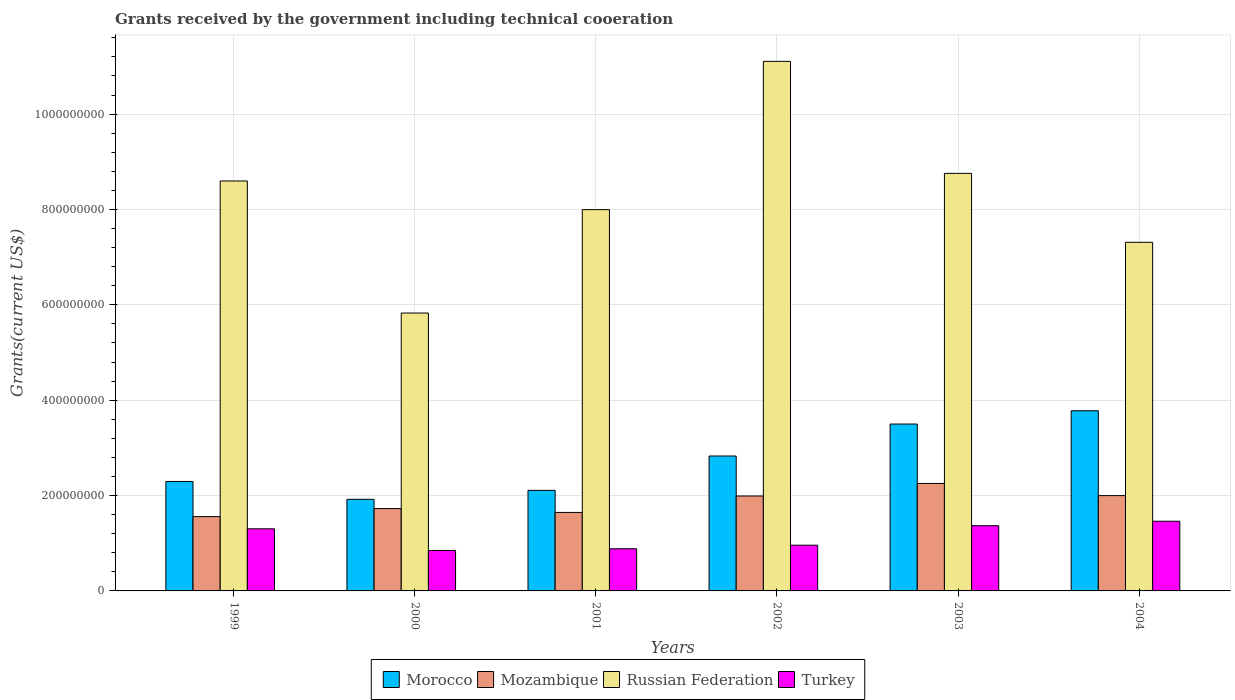How many groups of bars are there?
Ensure brevity in your answer.  6. Are the number of bars on each tick of the X-axis equal?
Provide a succinct answer. Yes. How many bars are there on the 1st tick from the left?
Your response must be concise. 4. What is the total grants received by the government in Russian Federation in 2000?
Provide a succinct answer. 5.83e+08. Across all years, what is the maximum total grants received by the government in Russian Federation?
Offer a very short reply. 1.11e+09. Across all years, what is the minimum total grants received by the government in Mozambique?
Provide a short and direct response. 1.56e+08. In which year was the total grants received by the government in Morocco maximum?
Ensure brevity in your answer.  2004. In which year was the total grants received by the government in Turkey minimum?
Give a very brief answer. 2000. What is the total total grants received by the government in Morocco in the graph?
Your answer should be very brief. 1.64e+09. What is the difference between the total grants received by the government in Turkey in 2001 and that in 2003?
Make the answer very short. -4.84e+07. What is the difference between the total grants received by the government in Russian Federation in 2000 and the total grants received by the government in Turkey in 1999?
Your response must be concise. 4.53e+08. What is the average total grants received by the government in Morocco per year?
Your response must be concise. 2.74e+08. In the year 2003, what is the difference between the total grants received by the government in Turkey and total grants received by the government in Mozambique?
Offer a very short reply. -8.86e+07. In how many years, is the total grants received by the government in Turkey greater than 680000000 US$?
Offer a terse response. 0. What is the ratio of the total grants received by the government in Turkey in 2001 to that in 2003?
Your answer should be compact. 0.65. Is the total grants received by the government in Morocco in 2000 less than that in 2004?
Keep it short and to the point. Yes. Is the difference between the total grants received by the government in Turkey in 2001 and 2003 greater than the difference between the total grants received by the government in Mozambique in 2001 and 2003?
Offer a terse response. Yes. What is the difference between the highest and the second highest total grants received by the government in Turkey?
Offer a terse response. 9.33e+06. What is the difference between the highest and the lowest total grants received by the government in Morocco?
Provide a succinct answer. 1.86e+08. Is it the case that in every year, the sum of the total grants received by the government in Turkey and total grants received by the government in Russian Federation is greater than the sum of total grants received by the government in Mozambique and total grants received by the government in Morocco?
Keep it short and to the point. Yes. What does the 3rd bar from the left in 2003 represents?
Offer a very short reply. Russian Federation. Is it the case that in every year, the sum of the total grants received by the government in Morocco and total grants received by the government in Mozambique is greater than the total grants received by the government in Russian Federation?
Give a very brief answer. No. How many years are there in the graph?
Offer a very short reply. 6. What is the difference between two consecutive major ticks on the Y-axis?
Offer a terse response. 2.00e+08. Does the graph contain grids?
Ensure brevity in your answer.  Yes. Where does the legend appear in the graph?
Give a very brief answer. Bottom center. How are the legend labels stacked?
Give a very brief answer. Horizontal. What is the title of the graph?
Offer a terse response. Grants received by the government including technical cooeration. Does "Marshall Islands" appear as one of the legend labels in the graph?
Your answer should be compact. No. What is the label or title of the Y-axis?
Offer a terse response. Grants(current US$). What is the Grants(current US$) of Morocco in 1999?
Provide a short and direct response. 2.30e+08. What is the Grants(current US$) in Mozambique in 1999?
Offer a very short reply. 1.56e+08. What is the Grants(current US$) in Russian Federation in 1999?
Provide a short and direct response. 8.60e+08. What is the Grants(current US$) in Turkey in 1999?
Provide a short and direct response. 1.30e+08. What is the Grants(current US$) of Morocco in 2000?
Offer a terse response. 1.92e+08. What is the Grants(current US$) in Mozambique in 2000?
Ensure brevity in your answer.  1.73e+08. What is the Grants(current US$) of Russian Federation in 2000?
Offer a very short reply. 5.83e+08. What is the Grants(current US$) of Turkey in 2000?
Offer a very short reply. 8.48e+07. What is the Grants(current US$) in Morocco in 2001?
Offer a very short reply. 2.11e+08. What is the Grants(current US$) in Mozambique in 2001?
Provide a succinct answer. 1.65e+08. What is the Grants(current US$) in Russian Federation in 2001?
Provide a succinct answer. 8.00e+08. What is the Grants(current US$) of Turkey in 2001?
Provide a succinct answer. 8.84e+07. What is the Grants(current US$) of Morocco in 2002?
Keep it short and to the point. 2.83e+08. What is the Grants(current US$) of Mozambique in 2002?
Provide a short and direct response. 1.99e+08. What is the Grants(current US$) in Russian Federation in 2002?
Make the answer very short. 1.11e+09. What is the Grants(current US$) in Turkey in 2002?
Give a very brief answer. 9.59e+07. What is the Grants(current US$) of Morocco in 2003?
Offer a very short reply. 3.50e+08. What is the Grants(current US$) of Mozambique in 2003?
Provide a succinct answer. 2.25e+08. What is the Grants(current US$) in Russian Federation in 2003?
Provide a succinct answer. 8.76e+08. What is the Grants(current US$) of Turkey in 2003?
Your response must be concise. 1.37e+08. What is the Grants(current US$) of Morocco in 2004?
Your answer should be very brief. 3.78e+08. What is the Grants(current US$) of Mozambique in 2004?
Provide a succinct answer. 2.00e+08. What is the Grants(current US$) of Russian Federation in 2004?
Your answer should be compact. 7.31e+08. What is the Grants(current US$) of Turkey in 2004?
Provide a short and direct response. 1.46e+08. Across all years, what is the maximum Grants(current US$) in Morocco?
Provide a succinct answer. 3.78e+08. Across all years, what is the maximum Grants(current US$) in Mozambique?
Your answer should be very brief. 2.25e+08. Across all years, what is the maximum Grants(current US$) of Russian Federation?
Your answer should be very brief. 1.11e+09. Across all years, what is the maximum Grants(current US$) of Turkey?
Make the answer very short. 1.46e+08. Across all years, what is the minimum Grants(current US$) in Morocco?
Offer a very short reply. 1.92e+08. Across all years, what is the minimum Grants(current US$) of Mozambique?
Keep it short and to the point. 1.56e+08. Across all years, what is the minimum Grants(current US$) in Russian Federation?
Keep it short and to the point. 5.83e+08. Across all years, what is the minimum Grants(current US$) of Turkey?
Give a very brief answer. 8.48e+07. What is the total Grants(current US$) of Morocco in the graph?
Offer a very short reply. 1.64e+09. What is the total Grants(current US$) in Mozambique in the graph?
Make the answer very short. 1.12e+09. What is the total Grants(current US$) of Russian Federation in the graph?
Your answer should be compact. 4.96e+09. What is the total Grants(current US$) of Turkey in the graph?
Make the answer very short. 6.82e+08. What is the difference between the Grants(current US$) of Morocco in 1999 and that in 2000?
Your answer should be very brief. 3.75e+07. What is the difference between the Grants(current US$) in Mozambique in 1999 and that in 2000?
Provide a short and direct response. -1.69e+07. What is the difference between the Grants(current US$) of Russian Federation in 1999 and that in 2000?
Ensure brevity in your answer.  2.77e+08. What is the difference between the Grants(current US$) of Turkey in 1999 and that in 2000?
Keep it short and to the point. 4.55e+07. What is the difference between the Grants(current US$) in Morocco in 1999 and that in 2001?
Provide a succinct answer. 1.87e+07. What is the difference between the Grants(current US$) of Mozambique in 1999 and that in 2001?
Keep it short and to the point. -8.79e+06. What is the difference between the Grants(current US$) of Russian Federation in 1999 and that in 2001?
Make the answer very short. 6.01e+07. What is the difference between the Grants(current US$) in Turkey in 1999 and that in 2001?
Give a very brief answer. 4.18e+07. What is the difference between the Grants(current US$) of Morocco in 1999 and that in 2002?
Give a very brief answer. -5.34e+07. What is the difference between the Grants(current US$) of Mozambique in 1999 and that in 2002?
Offer a very short reply. -4.32e+07. What is the difference between the Grants(current US$) of Russian Federation in 1999 and that in 2002?
Ensure brevity in your answer.  -2.51e+08. What is the difference between the Grants(current US$) in Turkey in 1999 and that in 2002?
Your response must be concise. 3.44e+07. What is the difference between the Grants(current US$) in Morocco in 1999 and that in 2003?
Offer a very short reply. -1.20e+08. What is the difference between the Grants(current US$) of Mozambique in 1999 and that in 2003?
Your response must be concise. -6.96e+07. What is the difference between the Grants(current US$) of Russian Federation in 1999 and that in 2003?
Keep it short and to the point. -1.59e+07. What is the difference between the Grants(current US$) in Turkey in 1999 and that in 2003?
Your answer should be very brief. -6.54e+06. What is the difference between the Grants(current US$) in Morocco in 1999 and that in 2004?
Make the answer very short. -1.48e+08. What is the difference between the Grants(current US$) of Mozambique in 1999 and that in 2004?
Ensure brevity in your answer.  -4.41e+07. What is the difference between the Grants(current US$) in Russian Federation in 1999 and that in 2004?
Provide a short and direct response. 1.29e+08. What is the difference between the Grants(current US$) in Turkey in 1999 and that in 2004?
Your answer should be compact. -1.59e+07. What is the difference between the Grants(current US$) of Morocco in 2000 and that in 2001?
Ensure brevity in your answer.  -1.88e+07. What is the difference between the Grants(current US$) in Mozambique in 2000 and that in 2001?
Provide a short and direct response. 8.07e+06. What is the difference between the Grants(current US$) of Russian Federation in 2000 and that in 2001?
Offer a very short reply. -2.17e+08. What is the difference between the Grants(current US$) of Turkey in 2000 and that in 2001?
Provide a short and direct response. -3.63e+06. What is the difference between the Grants(current US$) in Morocco in 2000 and that in 2002?
Your answer should be very brief. -9.08e+07. What is the difference between the Grants(current US$) of Mozambique in 2000 and that in 2002?
Keep it short and to the point. -2.64e+07. What is the difference between the Grants(current US$) in Russian Federation in 2000 and that in 2002?
Your answer should be compact. -5.28e+08. What is the difference between the Grants(current US$) in Turkey in 2000 and that in 2002?
Your response must be concise. -1.11e+07. What is the difference between the Grants(current US$) in Morocco in 2000 and that in 2003?
Your response must be concise. -1.58e+08. What is the difference between the Grants(current US$) in Mozambique in 2000 and that in 2003?
Offer a terse response. -5.27e+07. What is the difference between the Grants(current US$) in Russian Federation in 2000 and that in 2003?
Keep it short and to the point. -2.93e+08. What is the difference between the Grants(current US$) of Turkey in 2000 and that in 2003?
Ensure brevity in your answer.  -5.20e+07. What is the difference between the Grants(current US$) in Morocco in 2000 and that in 2004?
Your response must be concise. -1.86e+08. What is the difference between the Grants(current US$) in Mozambique in 2000 and that in 2004?
Your answer should be compact. -2.72e+07. What is the difference between the Grants(current US$) of Russian Federation in 2000 and that in 2004?
Provide a short and direct response. -1.48e+08. What is the difference between the Grants(current US$) of Turkey in 2000 and that in 2004?
Keep it short and to the point. -6.13e+07. What is the difference between the Grants(current US$) of Morocco in 2001 and that in 2002?
Provide a succinct answer. -7.20e+07. What is the difference between the Grants(current US$) in Mozambique in 2001 and that in 2002?
Provide a succinct answer. -3.45e+07. What is the difference between the Grants(current US$) in Russian Federation in 2001 and that in 2002?
Offer a very short reply. -3.11e+08. What is the difference between the Grants(current US$) in Turkey in 2001 and that in 2002?
Your answer should be compact. -7.48e+06. What is the difference between the Grants(current US$) in Morocco in 2001 and that in 2003?
Offer a terse response. -1.39e+08. What is the difference between the Grants(current US$) in Mozambique in 2001 and that in 2003?
Keep it short and to the point. -6.08e+07. What is the difference between the Grants(current US$) in Russian Federation in 2001 and that in 2003?
Make the answer very short. -7.60e+07. What is the difference between the Grants(current US$) in Turkey in 2001 and that in 2003?
Keep it short and to the point. -4.84e+07. What is the difference between the Grants(current US$) of Morocco in 2001 and that in 2004?
Offer a terse response. -1.67e+08. What is the difference between the Grants(current US$) in Mozambique in 2001 and that in 2004?
Make the answer very short. -3.53e+07. What is the difference between the Grants(current US$) of Russian Federation in 2001 and that in 2004?
Offer a very short reply. 6.85e+07. What is the difference between the Grants(current US$) of Turkey in 2001 and that in 2004?
Provide a short and direct response. -5.77e+07. What is the difference between the Grants(current US$) in Morocco in 2002 and that in 2003?
Your answer should be compact. -6.71e+07. What is the difference between the Grants(current US$) in Mozambique in 2002 and that in 2003?
Provide a succinct answer. -2.63e+07. What is the difference between the Grants(current US$) in Russian Federation in 2002 and that in 2003?
Your response must be concise. 2.35e+08. What is the difference between the Grants(current US$) of Turkey in 2002 and that in 2003?
Offer a very short reply. -4.09e+07. What is the difference between the Grants(current US$) in Morocco in 2002 and that in 2004?
Offer a very short reply. -9.49e+07. What is the difference between the Grants(current US$) in Mozambique in 2002 and that in 2004?
Make the answer very short. -8.20e+05. What is the difference between the Grants(current US$) in Russian Federation in 2002 and that in 2004?
Give a very brief answer. 3.79e+08. What is the difference between the Grants(current US$) in Turkey in 2002 and that in 2004?
Offer a terse response. -5.02e+07. What is the difference between the Grants(current US$) of Morocco in 2003 and that in 2004?
Offer a very short reply. -2.78e+07. What is the difference between the Grants(current US$) in Mozambique in 2003 and that in 2004?
Provide a succinct answer. 2.55e+07. What is the difference between the Grants(current US$) of Russian Federation in 2003 and that in 2004?
Keep it short and to the point. 1.44e+08. What is the difference between the Grants(current US$) of Turkey in 2003 and that in 2004?
Your answer should be compact. -9.33e+06. What is the difference between the Grants(current US$) in Morocco in 1999 and the Grants(current US$) in Mozambique in 2000?
Give a very brief answer. 5.69e+07. What is the difference between the Grants(current US$) of Morocco in 1999 and the Grants(current US$) of Russian Federation in 2000?
Provide a short and direct response. -3.53e+08. What is the difference between the Grants(current US$) of Morocco in 1999 and the Grants(current US$) of Turkey in 2000?
Your answer should be very brief. 1.45e+08. What is the difference between the Grants(current US$) in Mozambique in 1999 and the Grants(current US$) in Russian Federation in 2000?
Give a very brief answer. -4.27e+08. What is the difference between the Grants(current US$) in Mozambique in 1999 and the Grants(current US$) in Turkey in 2000?
Keep it short and to the point. 7.10e+07. What is the difference between the Grants(current US$) of Russian Federation in 1999 and the Grants(current US$) of Turkey in 2000?
Make the answer very short. 7.75e+08. What is the difference between the Grants(current US$) in Morocco in 1999 and the Grants(current US$) in Mozambique in 2001?
Keep it short and to the point. 6.50e+07. What is the difference between the Grants(current US$) in Morocco in 1999 and the Grants(current US$) in Russian Federation in 2001?
Offer a very short reply. -5.70e+08. What is the difference between the Grants(current US$) of Morocco in 1999 and the Grants(current US$) of Turkey in 2001?
Your answer should be compact. 1.41e+08. What is the difference between the Grants(current US$) of Mozambique in 1999 and the Grants(current US$) of Russian Federation in 2001?
Give a very brief answer. -6.44e+08. What is the difference between the Grants(current US$) of Mozambique in 1999 and the Grants(current US$) of Turkey in 2001?
Keep it short and to the point. 6.74e+07. What is the difference between the Grants(current US$) in Russian Federation in 1999 and the Grants(current US$) in Turkey in 2001?
Your answer should be compact. 7.71e+08. What is the difference between the Grants(current US$) in Morocco in 1999 and the Grants(current US$) in Mozambique in 2002?
Keep it short and to the point. 3.05e+07. What is the difference between the Grants(current US$) in Morocco in 1999 and the Grants(current US$) in Russian Federation in 2002?
Your answer should be very brief. -8.81e+08. What is the difference between the Grants(current US$) of Morocco in 1999 and the Grants(current US$) of Turkey in 2002?
Ensure brevity in your answer.  1.34e+08. What is the difference between the Grants(current US$) of Mozambique in 1999 and the Grants(current US$) of Russian Federation in 2002?
Your response must be concise. -9.55e+08. What is the difference between the Grants(current US$) in Mozambique in 1999 and the Grants(current US$) in Turkey in 2002?
Your response must be concise. 5.99e+07. What is the difference between the Grants(current US$) of Russian Federation in 1999 and the Grants(current US$) of Turkey in 2002?
Your answer should be very brief. 7.64e+08. What is the difference between the Grants(current US$) of Morocco in 1999 and the Grants(current US$) of Mozambique in 2003?
Your response must be concise. 4.20e+06. What is the difference between the Grants(current US$) in Morocco in 1999 and the Grants(current US$) in Russian Federation in 2003?
Provide a succinct answer. -6.46e+08. What is the difference between the Grants(current US$) of Morocco in 1999 and the Grants(current US$) of Turkey in 2003?
Your answer should be very brief. 9.28e+07. What is the difference between the Grants(current US$) in Mozambique in 1999 and the Grants(current US$) in Russian Federation in 2003?
Provide a succinct answer. -7.20e+08. What is the difference between the Grants(current US$) in Mozambique in 1999 and the Grants(current US$) in Turkey in 2003?
Provide a short and direct response. 1.90e+07. What is the difference between the Grants(current US$) in Russian Federation in 1999 and the Grants(current US$) in Turkey in 2003?
Make the answer very short. 7.23e+08. What is the difference between the Grants(current US$) in Morocco in 1999 and the Grants(current US$) in Mozambique in 2004?
Keep it short and to the point. 2.97e+07. What is the difference between the Grants(current US$) of Morocco in 1999 and the Grants(current US$) of Russian Federation in 2004?
Your response must be concise. -5.02e+08. What is the difference between the Grants(current US$) of Morocco in 1999 and the Grants(current US$) of Turkey in 2004?
Make the answer very short. 8.34e+07. What is the difference between the Grants(current US$) in Mozambique in 1999 and the Grants(current US$) in Russian Federation in 2004?
Give a very brief answer. -5.75e+08. What is the difference between the Grants(current US$) of Mozambique in 1999 and the Grants(current US$) of Turkey in 2004?
Ensure brevity in your answer.  9.69e+06. What is the difference between the Grants(current US$) in Russian Federation in 1999 and the Grants(current US$) in Turkey in 2004?
Offer a terse response. 7.14e+08. What is the difference between the Grants(current US$) in Morocco in 2000 and the Grants(current US$) in Mozambique in 2001?
Ensure brevity in your answer.  2.75e+07. What is the difference between the Grants(current US$) in Morocco in 2000 and the Grants(current US$) in Russian Federation in 2001?
Offer a terse response. -6.08e+08. What is the difference between the Grants(current US$) of Morocco in 2000 and the Grants(current US$) of Turkey in 2001?
Your answer should be compact. 1.04e+08. What is the difference between the Grants(current US$) of Mozambique in 2000 and the Grants(current US$) of Russian Federation in 2001?
Offer a terse response. -6.27e+08. What is the difference between the Grants(current US$) in Mozambique in 2000 and the Grants(current US$) in Turkey in 2001?
Offer a very short reply. 8.42e+07. What is the difference between the Grants(current US$) in Russian Federation in 2000 and the Grants(current US$) in Turkey in 2001?
Offer a terse response. 4.94e+08. What is the difference between the Grants(current US$) in Morocco in 2000 and the Grants(current US$) in Mozambique in 2002?
Provide a succinct answer. -6.98e+06. What is the difference between the Grants(current US$) in Morocco in 2000 and the Grants(current US$) in Russian Federation in 2002?
Your answer should be compact. -9.18e+08. What is the difference between the Grants(current US$) in Morocco in 2000 and the Grants(current US$) in Turkey in 2002?
Make the answer very short. 9.62e+07. What is the difference between the Grants(current US$) in Mozambique in 2000 and the Grants(current US$) in Russian Federation in 2002?
Offer a terse response. -9.38e+08. What is the difference between the Grants(current US$) of Mozambique in 2000 and the Grants(current US$) of Turkey in 2002?
Ensure brevity in your answer.  7.68e+07. What is the difference between the Grants(current US$) of Russian Federation in 2000 and the Grants(current US$) of Turkey in 2002?
Your response must be concise. 4.87e+08. What is the difference between the Grants(current US$) in Morocco in 2000 and the Grants(current US$) in Mozambique in 2003?
Your response must be concise. -3.33e+07. What is the difference between the Grants(current US$) in Morocco in 2000 and the Grants(current US$) in Russian Federation in 2003?
Keep it short and to the point. -6.84e+08. What is the difference between the Grants(current US$) of Morocco in 2000 and the Grants(current US$) of Turkey in 2003?
Keep it short and to the point. 5.53e+07. What is the difference between the Grants(current US$) in Mozambique in 2000 and the Grants(current US$) in Russian Federation in 2003?
Give a very brief answer. -7.03e+08. What is the difference between the Grants(current US$) in Mozambique in 2000 and the Grants(current US$) in Turkey in 2003?
Give a very brief answer. 3.59e+07. What is the difference between the Grants(current US$) in Russian Federation in 2000 and the Grants(current US$) in Turkey in 2003?
Offer a terse response. 4.46e+08. What is the difference between the Grants(current US$) in Morocco in 2000 and the Grants(current US$) in Mozambique in 2004?
Keep it short and to the point. -7.80e+06. What is the difference between the Grants(current US$) in Morocco in 2000 and the Grants(current US$) in Russian Federation in 2004?
Keep it short and to the point. -5.39e+08. What is the difference between the Grants(current US$) of Morocco in 2000 and the Grants(current US$) of Turkey in 2004?
Give a very brief answer. 4.60e+07. What is the difference between the Grants(current US$) of Mozambique in 2000 and the Grants(current US$) of Russian Federation in 2004?
Give a very brief answer. -5.58e+08. What is the difference between the Grants(current US$) of Mozambique in 2000 and the Grants(current US$) of Turkey in 2004?
Ensure brevity in your answer.  2.66e+07. What is the difference between the Grants(current US$) in Russian Federation in 2000 and the Grants(current US$) in Turkey in 2004?
Keep it short and to the point. 4.37e+08. What is the difference between the Grants(current US$) in Morocco in 2001 and the Grants(current US$) in Mozambique in 2002?
Your answer should be compact. 1.18e+07. What is the difference between the Grants(current US$) in Morocco in 2001 and the Grants(current US$) in Russian Federation in 2002?
Give a very brief answer. -9.00e+08. What is the difference between the Grants(current US$) in Morocco in 2001 and the Grants(current US$) in Turkey in 2002?
Your response must be concise. 1.15e+08. What is the difference between the Grants(current US$) of Mozambique in 2001 and the Grants(current US$) of Russian Federation in 2002?
Offer a very short reply. -9.46e+08. What is the difference between the Grants(current US$) in Mozambique in 2001 and the Grants(current US$) in Turkey in 2002?
Provide a succinct answer. 6.87e+07. What is the difference between the Grants(current US$) of Russian Federation in 2001 and the Grants(current US$) of Turkey in 2002?
Offer a terse response. 7.04e+08. What is the difference between the Grants(current US$) in Morocco in 2001 and the Grants(current US$) in Mozambique in 2003?
Provide a short and direct response. -1.45e+07. What is the difference between the Grants(current US$) in Morocco in 2001 and the Grants(current US$) in Russian Federation in 2003?
Give a very brief answer. -6.65e+08. What is the difference between the Grants(current US$) of Morocco in 2001 and the Grants(current US$) of Turkey in 2003?
Give a very brief answer. 7.41e+07. What is the difference between the Grants(current US$) in Mozambique in 2001 and the Grants(current US$) in Russian Federation in 2003?
Offer a very short reply. -7.11e+08. What is the difference between the Grants(current US$) in Mozambique in 2001 and the Grants(current US$) in Turkey in 2003?
Your answer should be very brief. 2.78e+07. What is the difference between the Grants(current US$) of Russian Federation in 2001 and the Grants(current US$) of Turkey in 2003?
Ensure brevity in your answer.  6.63e+08. What is the difference between the Grants(current US$) of Morocco in 2001 and the Grants(current US$) of Mozambique in 2004?
Keep it short and to the point. 1.10e+07. What is the difference between the Grants(current US$) in Morocco in 2001 and the Grants(current US$) in Russian Federation in 2004?
Your answer should be compact. -5.20e+08. What is the difference between the Grants(current US$) in Morocco in 2001 and the Grants(current US$) in Turkey in 2004?
Offer a terse response. 6.48e+07. What is the difference between the Grants(current US$) in Mozambique in 2001 and the Grants(current US$) in Russian Federation in 2004?
Provide a short and direct response. -5.67e+08. What is the difference between the Grants(current US$) of Mozambique in 2001 and the Grants(current US$) of Turkey in 2004?
Give a very brief answer. 1.85e+07. What is the difference between the Grants(current US$) of Russian Federation in 2001 and the Grants(current US$) of Turkey in 2004?
Provide a short and direct response. 6.53e+08. What is the difference between the Grants(current US$) of Morocco in 2002 and the Grants(current US$) of Mozambique in 2003?
Provide a succinct answer. 5.76e+07. What is the difference between the Grants(current US$) in Morocco in 2002 and the Grants(current US$) in Russian Federation in 2003?
Offer a terse response. -5.93e+08. What is the difference between the Grants(current US$) of Morocco in 2002 and the Grants(current US$) of Turkey in 2003?
Provide a short and direct response. 1.46e+08. What is the difference between the Grants(current US$) of Mozambique in 2002 and the Grants(current US$) of Russian Federation in 2003?
Offer a very short reply. -6.77e+08. What is the difference between the Grants(current US$) in Mozambique in 2002 and the Grants(current US$) in Turkey in 2003?
Your answer should be compact. 6.23e+07. What is the difference between the Grants(current US$) of Russian Federation in 2002 and the Grants(current US$) of Turkey in 2003?
Provide a short and direct response. 9.74e+08. What is the difference between the Grants(current US$) of Morocco in 2002 and the Grants(current US$) of Mozambique in 2004?
Keep it short and to the point. 8.30e+07. What is the difference between the Grants(current US$) of Morocco in 2002 and the Grants(current US$) of Russian Federation in 2004?
Your answer should be very brief. -4.48e+08. What is the difference between the Grants(current US$) in Morocco in 2002 and the Grants(current US$) in Turkey in 2004?
Offer a very short reply. 1.37e+08. What is the difference between the Grants(current US$) of Mozambique in 2002 and the Grants(current US$) of Russian Federation in 2004?
Your response must be concise. -5.32e+08. What is the difference between the Grants(current US$) of Mozambique in 2002 and the Grants(current US$) of Turkey in 2004?
Provide a succinct answer. 5.29e+07. What is the difference between the Grants(current US$) in Russian Federation in 2002 and the Grants(current US$) in Turkey in 2004?
Ensure brevity in your answer.  9.64e+08. What is the difference between the Grants(current US$) of Morocco in 2003 and the Grants(current US$) of Mozambique in 2004?
Make the answer very short. 1.50e+08. What is the difference between the Grants(current US$) of Morocco in 2003 and the Grants(current US$) of Russian Federation in 2004?
Provide a succinct answer. -3.81e+08. What is the difference between the Grants(current US$) in Morocco in 2003 and the Grants(current US$) in Turkey in 2004?
Keep it short and to the point. 2.04e+08. What is the difference between the Grants(current US$) in Mozambique in 2003 and the Grants(current US$) in Russian Federation in 2004?
Keep it short and to the point. -5.06e+08. What is the difference between the Grants(current US$) in Mozambique in 2003 and the Grants(current US$) in Turkey in 2004?
Give a very brief answer. 7.92e+07. What is the difference between the Grants(current US$) in Russian Federation in 2003 and the Grants(current US$) in Turkey in 2004?
Give a very brief answer. 7.30e+08. What is the average Grants(current US$) in Morocco per year?
Your response must be concise. 2.74e+08. What is the average Grants(current US$) of Mozambique per year?
Provide a short and direct response. 1.86e+08. What is the average Grants(current US$) of Russian Federation per year?
Ensure brevity in your answer.  8.27e+08. What is the average Grants(current US$) in Turkey per year?
Your answer should be compact. 1.14e+08. In the year 1999, what is the difference between the Grants(current US$) in Morocco and Grants(current US$) in Mozambique?
Give a very brief answer. 7.38e+07. In the year 1999, what is the difference between the Grants(current US$) of Morocco and Grants(current US$) of Russian Federation?
Keep it short and to the point. -6.30e+08. In the year 1999, what is the difference between the Grants(current US$) of Morocco and Grants(current US$) of Turkey?
Offer a very short reply. 9.93e+07. In the year 1999, what is the difference between the Grants(current US$) of Mozambique and Grants(current US$) of Russian Federation?
Provide a short and direct response. -7.04e+08. In the year 1999, what is the difference between the Grants(current US$) of Mozambique and Grants(current US$) of Turkey?
Your answer should be very brief. 2.56e+07. In the year 1999, what is the difference between the Grants(current US$) of Russian Federation and Grants(current US$) of Turkey?
Provide a short and direct response. 7.29e+08. In the year 2000, what is the difference between the Grants(current US$) in Morocco and Grants(current US$) in Mozambique?
Ensure brevity in your answer.  1.94e+07. In the year 2000, what is the difference between the Grants(current US$) in Morocco and Grants(current US$) in Russian Federation?
Your answer should be very brief. -3.91e+08. In the year 2000, what is the difference between the Grants(current US$) in Morocco and Grants(current US$) in Turkey?
Keep it short and to the point. 1.07e+08. In the year 2000, what is the difference between the Grants(current US$) of Mozambique and Grants(current US$) of Russian Federation?
Offer a terse response. -4.10e+08. In the year 2000, what is the difference between the Grants(current US$) in Mozambique and Grants(current US$) in Turkey?
Your answer should be very brief. 8.79e+07. In the year 2000, what is the difference between the Grants(current US$) in Russian Federation and Grants(current US$) in Turkey?
Make the answer very short. 4.98e+08. In the year 2001, what is the difference between the Grants(current US$) of Morocco and Grants(current US$) of Mozambique?
Offer a very short reply. 4.63e+07. In the year 2001, what is the difference between the Grants(current US$) of Morocco and Grants(current US$) of Russian Federation?
Keep it short and to the point. -5.89e+08. In the year 2001, what is the difference between the Grants(current US$) in Morocco and Grants(current US$) in Turkey?
Keep it short and to the point. 1.22e+08. In the year 2001, what is the difference between the Grants(current US$) in Mozambique and Grants(current US$) in Russian Federation?
Provide a short and direct response. -6.35e+08. In the year 2001, what is the difference between the Grants(current US$) in Mozambique and Grants(current US$) in Turkey?
Offer a very short reply. 7.62e+07. In the year 2001, what is the difference between the Grants(current US$) of Russian Federation and Grants(current US$) of Turkey?
Your response must be concise. 7.11e+08. In the year 2002, what is the difference between the Grants(current US$) in Morocco and Grants(current US$) in Mozambique?
Provide a short and direct response. 8.39e+07. In the year 2002, what is the difference between the Grants(current US$) of Morocco and Grants(current US$) of Russian Federation?
Provide a succinct answer. -8.28e+08. In the year 2002, what is the difference between the Grants(current US$) of Morocco and Grants(current US$) of Turkey?
Provide a short and direct response. 1.87e+08. In the year 2002, what is the difference between the Grants(current US$) of Mozambique and Grants(current US$) of Russian Federation?
Your answer should be compact. -9.12e+08. In the year 2002, what is the difference between the Grants(current US$) of Mozambique and Grants(current US$) of Turkey?
Your answer should be very brief. 1.03e+08. In the year 2002, what is the difference between the Grants(current US$) of Russian Federation and Grants(current US$) of Turkey?
Provide a short and direct response. 1.01e+09. In the year 2003, what is the difference between the Grants(current US$) of Morocco and Grants(current US$) of Mozambique?
Give a very brief answer. 1.25e+08. In the year 2003, what is the difference between the Grants(current US$) of Morocco and Grants(current US$) of Russian Federation?
Ensure brevity in your answer.  -5.26e+08. In the year 2003, what is the difference between the Grants(current US$) of Morocco and Grants(current US$) of Turkey?
Give a very brief answer. 2.13e+08. In the year 2003, what is the difference between the Grants(current US$) of Mozambique and Grants(current US$) of Russian Federation?
Offer a terse response. -6.50e+08. In the year 2003, what is the difference between the Grants(current US$) in Mozambique and Grants(current US$) in Turkey?
Your answer should be very brief. 8.86e+07. In the year 2003, what is the difference between the Grants(current US$) in Russian Federation and Grants(current US$) in Turkey?
Ensure brevity in your answer.  7.39e+08. In the year 2004, what is the difference between the Grants(current US$) in Morocco and Grants(current US$) in Mozambique?
Give a very brief answer. 1.78e+08. In the year 2004, what is the difference between the Grants(current US$) of Morocco and Grants(current US$) of Russian Federation?
Give a very brief answer. -3.53e+08. In the year 2004, what is the difference between the Grants(current US$) in Morocco and Grants(current US$) in Turkey?
Provide a short and direct response. 2.32e+08. In the year 2004, what is the difference between the Grants(current US$) in Mozambique and Grants(current US$) in Russian Federation?
Your answer should be very brief. -5.31e+08. In the year 2004, what is the difference between the Grants(current US$) of Mozambique and Grants(current US$) of Turkey?
Offer a terse response. 5.38e+07. In the year 2004, what is the difference between the Grants(current US$) in Russian Federation and Grants(current US$) in Turkey?
Provide a short and direct response. 5.85e+08. What is the ratio of the Grants(current US$) of Morocco in 1999 to that in 2000?
Ensure brevity in your answer.  1.2. What is the ratio of the Grants(current US$) in Mozambique in 1999 to that in 2000?
Make the answer very short. 0.9. What is the ratio of the Grants(current US$) in Russian Federation in 1999 to that in 2000?
Offer a terse response. 1.48. What is the ratio of the Grants(current US$) of Turkey in 1999 to that in 2000?
Keep it short and to the point. 1.54. What is the ratio of the Grants(current US$) in Morocco in 1999 to that in 2001?
Offer a terse response. 1.09. What is the ratio of the Grants(current US$) of Mozambique in 1999 to that in 2001?
Ensure brevity in your answer.  0.95. What is the ratio of the Grants(current US$) of Russian Federation in 1999 to that in 2001?
Provide a succinct answer. 1.08. What is the ratio of the Grants(current US$) of Turkey in 1999 to that in 2001?
Your answer should be very brief. 1.47. What is the ratio of the Grants(current US$) of Morocco in 1999 to that in 2002?
Provide a short and direct response. 0.81. What is the ratio of the Grants(current US$) in Mozambique in 1999 to that in 2002?
Offer a terse response. 0.78. What is the ratio of the Grants(current US$) in Russian Federation in 1999 to that in 2002?
Give a very brief answer. 0.77. What is the ratio of the Grants(current US$) in Turkey in 1999 to that in 2002?
Ensure brevity in your answer.  1.36. What is the ratio of the Grants(current US$) in Morocco in 1999 to that in 2003?
Your answer should be very brief. 0.66. What is the ratio of the Grants(current US$) in Mozambique in 1999 to that in 2003?
Provide a short and direct response. 0.69. What is the ratio of the Grants(current US$) in Russian Federation in 1999 to that in 2003?
Provide a succinct answer. 0.98. What is the ratio of the Grants(current US$) of Turkey in 1999 to that in 2003?
Make the answer very short. 0.95. What is the ratio of the Grants(current US$) in Morocco in 1999 to that in 2004?
Offer a very short reply. 0.61. What is the ratio of the Grants(current US$) in Mozambique in 1999 to that in 2004?
Make the answer very short. 0.78. What is the ratio of the Grants(current US$) of Russian Federation in 1999 to that in 2004?
Provide a succinct answer. 1.18. What is the ratio of the Grants(current US$) of Turkey in 1999 to that in 2004?
Provide a short and direct response. 0.89. What is the ratio of the Grants(current US$) in Morocco in 2000 to that in 2001?
Provide a short and direct response. 0.91. What is the ratio of the Grants(current US$) of Mozambique in 2000 to that in 2001?
Your answer should be compact. 1.05. What is the ratio of the Grants(current US$) in Russian Federation in 2000 to that in 2001?
Your answer should be very brief. 0.73. What is the ratio of the Grants(current US$) in Morocco in 2000 to that in 2002?
Provide a short and direct response. 0.68. What is the ratio of the Grants(current US$) of Mozambique in 2000 to that in 2002?
Your answer should be very brief. 0.87. What is the ratio of the Grants(current US$) of Russian Federation in 2000 to that in 2002?
Offer a very short reply. 0.52. What is the ratio of the Grants(current US$) in Turkey in 2000 to that in 2002?
Ensure brevity in your answer.  0.88. What is the ratio of the Grants(current US$) in Morocco in 2000 to that in 2003?
Provide a short and direct response. 0.55. What is the ratio of the Grants(current US$) in Mozambique in 2000 to that in 2003?
Offer a very short reply. 0.77. What is the ratio of the Grants(current US$) of Russian Federation in 2000 to that in 2003?
Your answer should be compact. 0.67. What is the ratio of the Grants(current US$) of Turkey in 2000 to that in 2003?
Make the answer very short. 0.62. What is the ratio of the Grants(current US$) of Morocco in 2000 to that in 2004?
Offer a very short reply. 0.51. What is the ratio of the Grants(current US$) of Mozambique in 2000 to that in 2004?
Offer a very short reply. 0.86. What is the ratio of the Grants(current US$) in Russian Federation in 2000 to that in 2004?
Provide a short and direct response. 0.8. What is the ratio of the Grants(current US$) of Turkey in 2000 to that in 2004?
Your answer should be very brief. 0.58. What is the ratio of the Grants(current US$) in Morocco in 2001 to that in 2002?
Your response must be concise. 0.75. What is the ratio of the Grants(current US$) of Mozambique in 2001 to that in 2002?
Your response must be concise. 0.83. What is the ratio of the Grants(current US$) in Russian Federation in 2001 to that in 2002?
Keep it short and to the point. 0.72. What is the ratio of the Grants(current US$) in Turkey in 2001 to that in 2002?
Keep it short and to the point. 0.92. What is the ratio of the Grants(current US$) of Morocco in 2001 to that in 2003?
Keep it short and to the point. 0.6. What is the ratio of the Grants(current US$) in Mozambique in 2001 to that in 2003?
Provide a succinct answer. 0.73. What is the ratio of the Grants(current US$) of Russian Federation in 2001 to that in 2003?
Make the answer very short. 0.91. What is the ratio of the Grants(current US$) of Turkey in 2001 to that in 2003?
Offer a terse response. 0.65. What is the ratio of the Grants(current US$) of Morocco in 2001 to that in 2004?
Provide a succinct answer. 0.56. What is the ratio of the Grants(current US$) of Mozambique in 2001 to that in 2004?
Your answer should be compact. 0.82. What is the ratio of the Grants(current US$) in Russian Federation in 2001 to that in 2004?
Give a very brief answer. 1.09. What is the ratio of the Grants(current US$) in Turkey in 2001 to that in 2004?
Make the answer very short. 0.61. What is the ratio of the Grants(current US$) in Morocco in 2002 to that in 2003?
Provide a succinct answer. 0.81. What is the ratio of the Grants(current US$) of Mozambique in 2002 to that in 2003?
Provide a succinct answer. 0.88. What is the ratio of the Grants(current US$) in Russian Federation in 2002 to that in 2003?
Your answer should be very brief. 1.27. What is the ratio of the Grants(current US$) in Turkey in 2002 to that in 2003?
Your answer should be compact. 0.7. What is the ratio of the Grants(current US$) of Morocco in 2002 to that in 2004?
Give a very brief answer. 0.75. What is the ratio of the Grants(current US$) in Mozambique in 2002 to that in 2004?
Your answer should be very brief. 1. What is the ratio of the Grants(current US$) in Russian Federation in 2002 to that in 2004?
Your answer should be very brief. 1.52. What is the ratio of the Grants(current US$) of Turkey in 2002 to that in 2004?
Offer a very short reply. 0.66. What is the ratio of the Grants(current US$) of Morocco in 2003 to that in 2004?
Provide a short and direct response. 0.93. What is the ratio of the Grants(current US$) of Mozambique in 2003 to that in 2004?
Offer a very short reply. 1.13. What is the ratio of the Grants(current US$) in Russian Federation in 2003 to that in 2004?
Offer a terse response. 1.2. What is the ratio of the Grants(current US$) of Turkey in 2003 to that in 2004?
Give a very brief answer. 0.94. What is the difference between the highest and the second highest Grants(current US$) of Morocco?
Your response must be concise. 2.78e+07. What is the difference between the highest and the second highest Grants(current US$) of Mozambique?
Give a very brief answer. 2.55e+07. What is the difference between the highest and the second highest Grants(current US$) of Russian Federation?
Offer a very short reply. 2.35e+08. What is the difference between the highest and the second highest Grants(current US$) in Turkey?
Your response must be concise. 9.33e+06. What is the difference between the highest and the lowest Grants(current US$) in Morocco?
Offer a very short reply. 1.86e+08. What is the difference between the highest and the lowest Grants(current US$) of Mozambique?
Make the answer very short. 6.96e+07. What is the difference between the highest and the lowest Grants(current US$) in Russian Federation?
Keep it short and to the point. 5.28e+08. What is the difference between the highest and the lowest Grants(current US$) of Turkey?
Make the answer very short. 6.13e+07. 